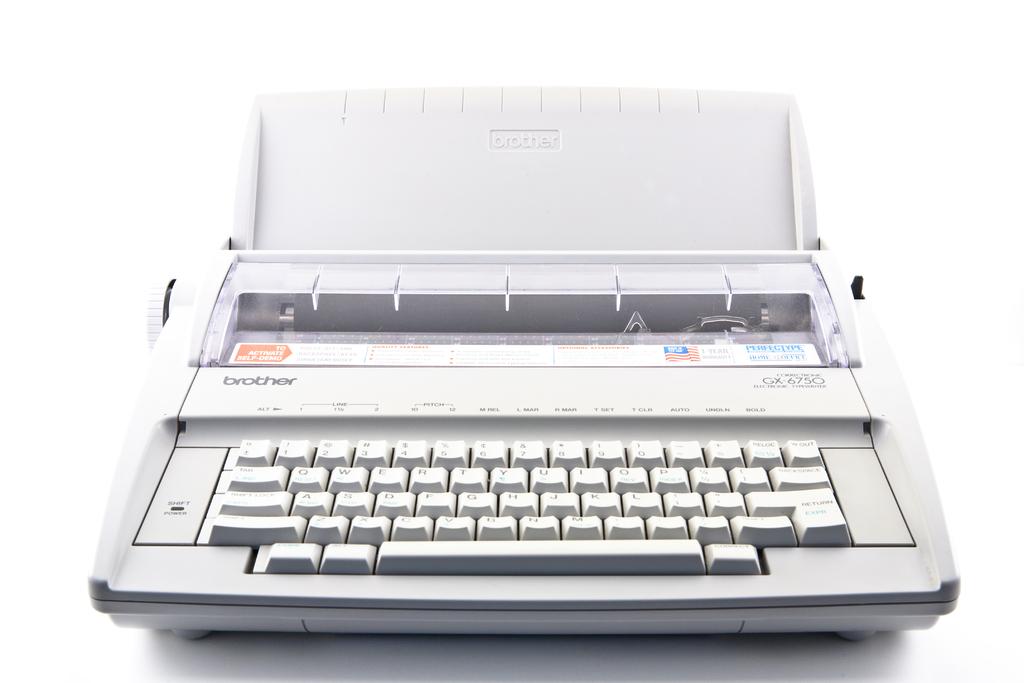What brand of typewriter is this?
Provide a succinct answer. Brother. 